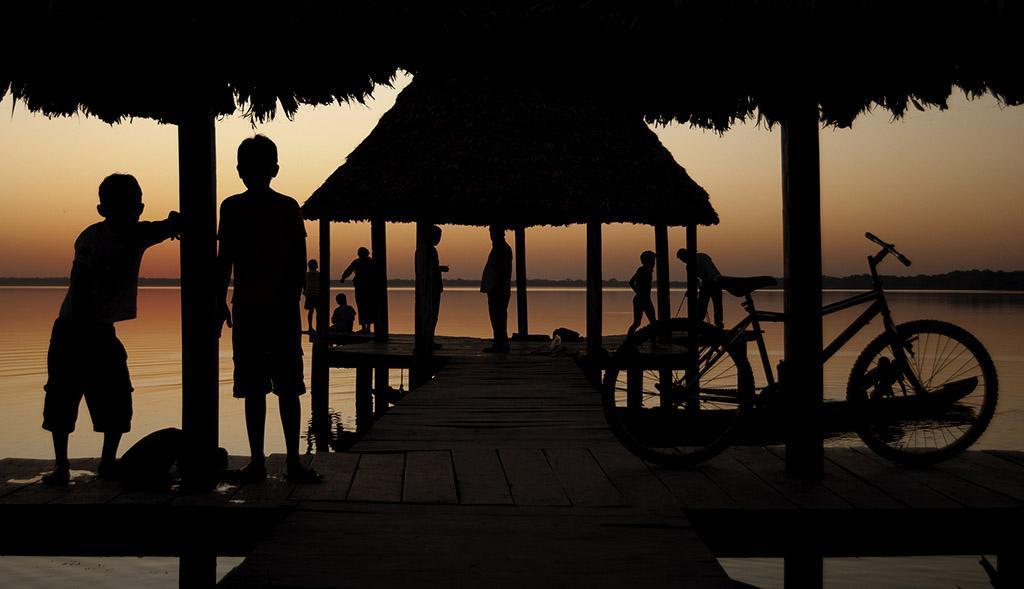How would you summarize this image in a sentence or two? This image is taken outdoors. In the background there is a river with water and there is the sky. At the bottom of the image there is a wooden platform. In the middle of the image there are two huts and there are many pillars. A bicycle is parked on the wooden platform. A few kids are standing on the wooden platform. 